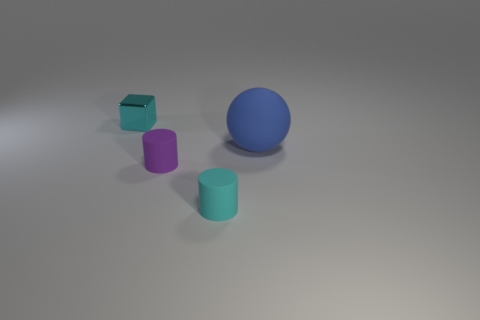Add 1 small purple matte objects. How many objects exist? 5 Subtract all blocks. How many objects are left? 3 Add 1 large blue things. How many large blue things are left? 2 Add 4 red rubber blocks. How many red rubber blocks exist? 4 Subtract 0 red balls. How many objects are left? 4 Subtract all cyan objects. Subtract all balls. How many objects are left? 1 